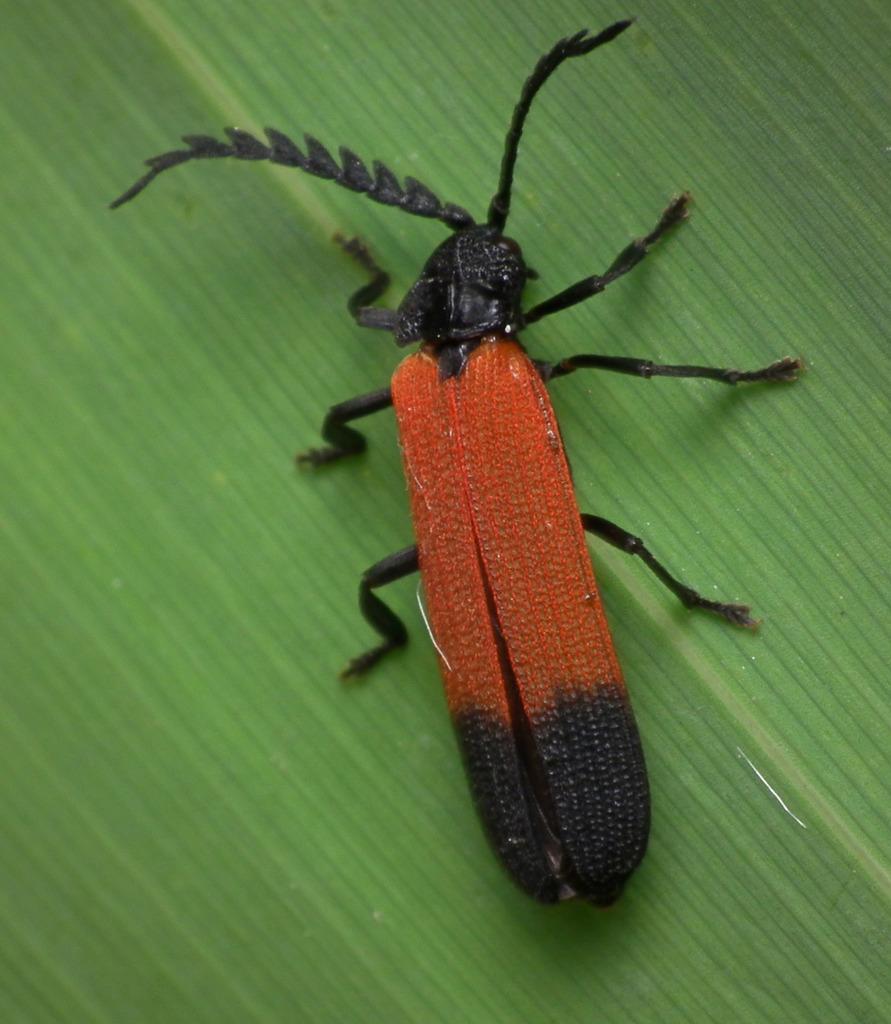Please provide a concise description of this image. In the picture I can see a Longhorn beetle which is on a greenery surface. 